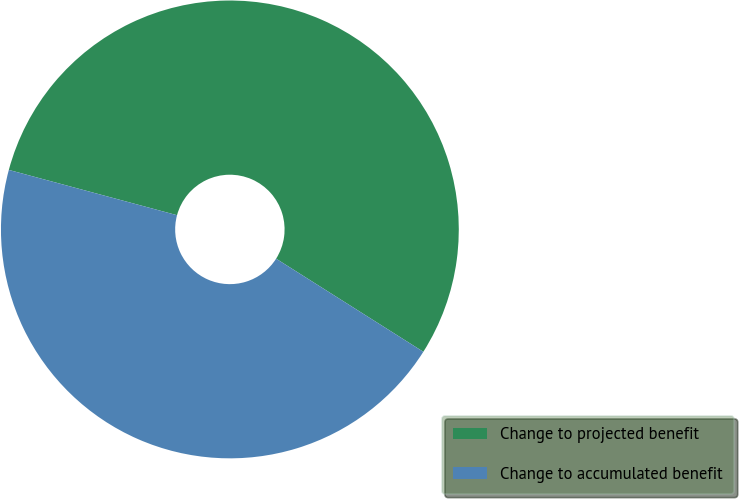Convert chart. <chart><loc_0><loc_0><loc_500><loc_500><pie_chart><fcel>Change to projected benefit<fcel>Change to accumulated benefit<nl><fcel>54.79%<fcel>45.21%<nl></chart> 